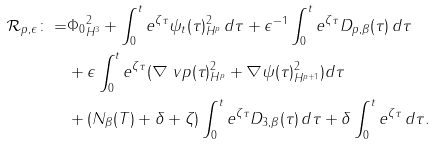<formula> <loc_0><loc_0><loc_500><loc_500>\mathcal { R } _ { p , \epsilon } \colon = & \| \Phi _ { 0 } \| ^ { 2 } _ { H ^ { 3 } } + \int ^ { t } _ { 0 } e ^ { \zeta \tau } \| \psi _ { t } ( \tau ) \| ^ { 2 } _ { H ^ { p } } \, d \tau + \epsilon ^ { - 1 } \int ^ { t } _ { 0 } e ^ { \zeta \tau } D _ { p , \beta } ( \tau ) \, d \tau \\ & + \epsilon \int ^ { t } _ { 0 } e ^ { \zeta \tau } ( \| \nabla \ v p ( \tau ) \| ^ { 2 } _ { H ^ { p } } + \| \nabla \psi ( \tau ) \| ^ { 2 } _ { H ^ { p + 1 } } ) d \tau \\ & + ( N _ { \beta } ( T ) + \delta + \zeta ) \int ^ { t } _ { 0 } e ^ { \zeta \tau } D _ { 3 , \beta } ( \tau ) \, d \tau + \delta \int ^ { t } _ { 0 } e ^ { \zeta \tau } \, d \tau .</formula> 